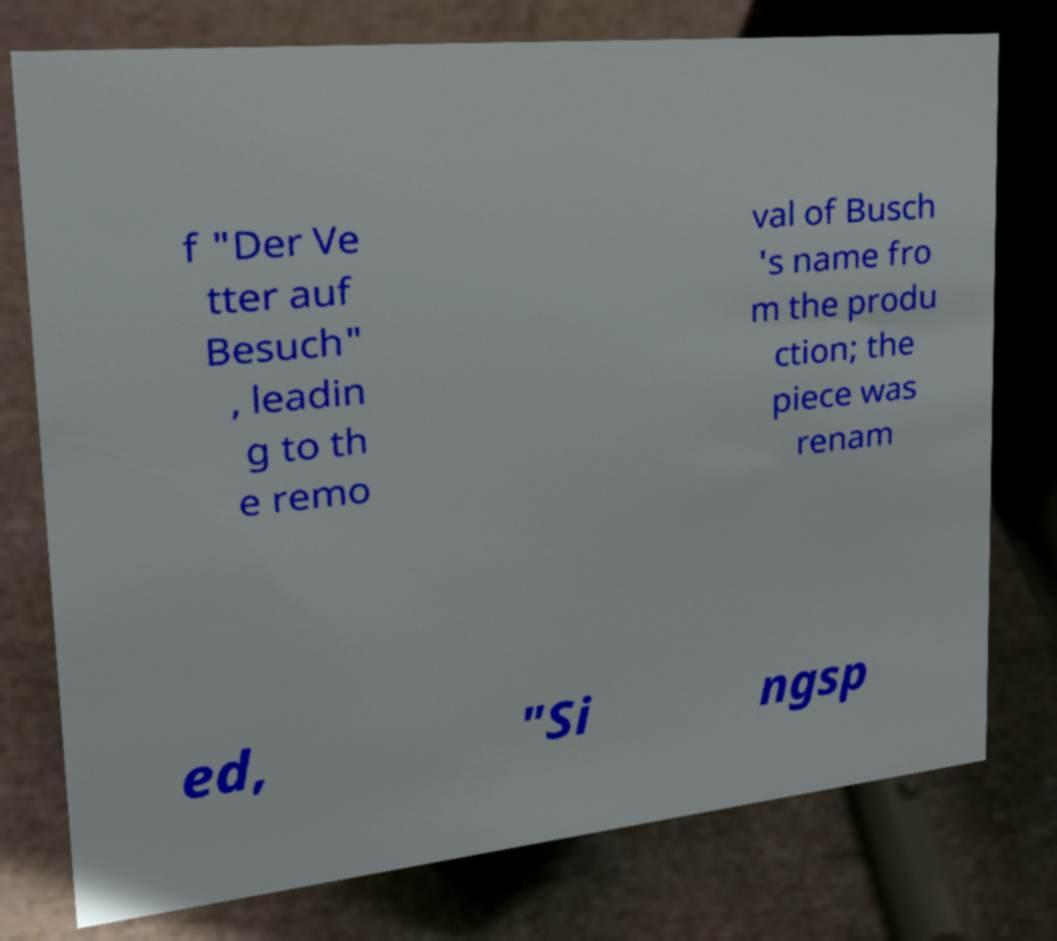For documentation purposes, I need the text within this image transcribed. Could you provide that? f "Der Ve tter auf Besuch" , leadin g to th e remo val of Busch 's name fro m the produ ction; the piece was renam ed, "Si ngsp 